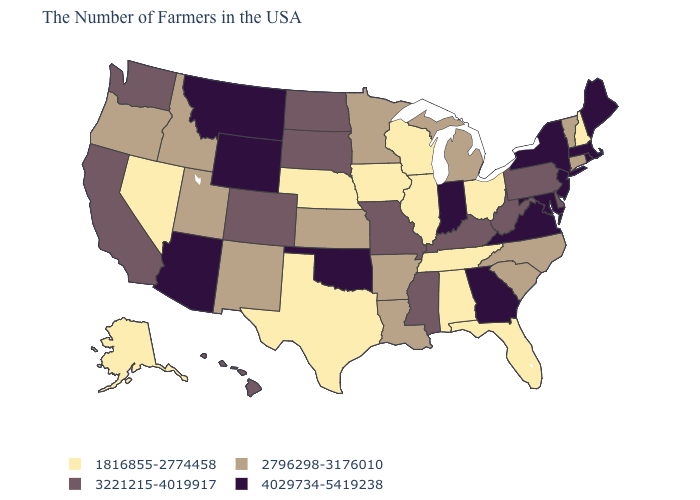Which states have the lowest value in the Northeast?
Be succinct. New Hampshire. What is the value of Iowa?
Concise answer only. 1816855-2774458. What is the value of Kansas?
Answer briefly. 2796298-3176010. Among the states that border Georgia , which have the lowest value?
Short answer required. Florida, Alabama, Tennessee. Does Washington have the lowest value in the West?
Short answer required. No. Among the states that border Rhode Island , which have the lowest value?
Be succinct. Connecticut. What is the value of Maine?
Give a very brief answer. 4029734-5419238. Name the states that have a value in the range 1816855-2774458?
Keep it brief. New Hampshire, Ohio, Florida, Alabama, Tennessee, Wisconsin, Illinois, Iowa, Nebraska, Texas, Nevada, Alaska. Which states have the lowest value in the Northeast?
Quick response, please. New Hampshire. What is the highest value in the USA?
Write a very short answer. 4029734-5419238. Name the states that have a value in the range 1816855-2774458?
Answer briefly. New Hampshire, Ohio, Florida, Alabama, Tennessee, Wisconsin, Illinois, Iowa, Nebraska, Texas, Nevada, Alaska. What is the lowest value in the USA?
Be succinct. 1816855-2774458. What is the value of Illinois?
Give a very brief answer. 1816855-2774458. Among the states that border South Carolina , does Georgia have the lowest value?
Write a very short answer. No. Does Hawaii have a higher value than New Hampshire?
Answer briefly. Yes. 